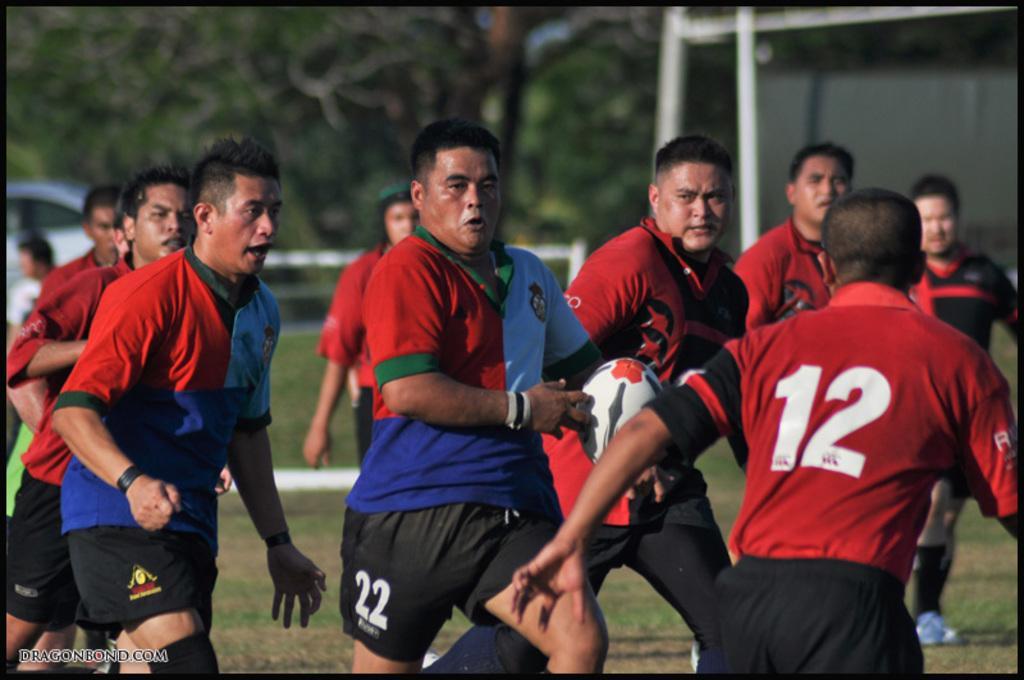Could you give a brief overview of what you see in this image? In the foreground of the picture we can see people running playing rugby. In the background there are trees, poles, car and greenery. 